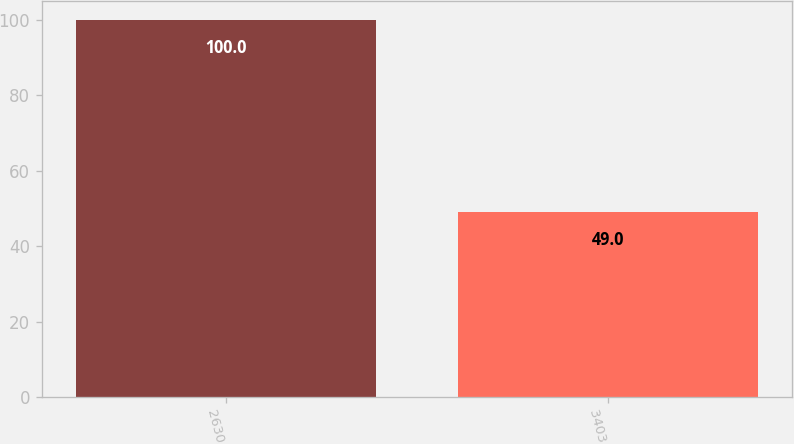<chart> <loc_0><loc_0><loc_500><loc_500><bar_chart><fcel>2630<fcel>3403<nl><fcel>100<fcel>49<nl></chart> 